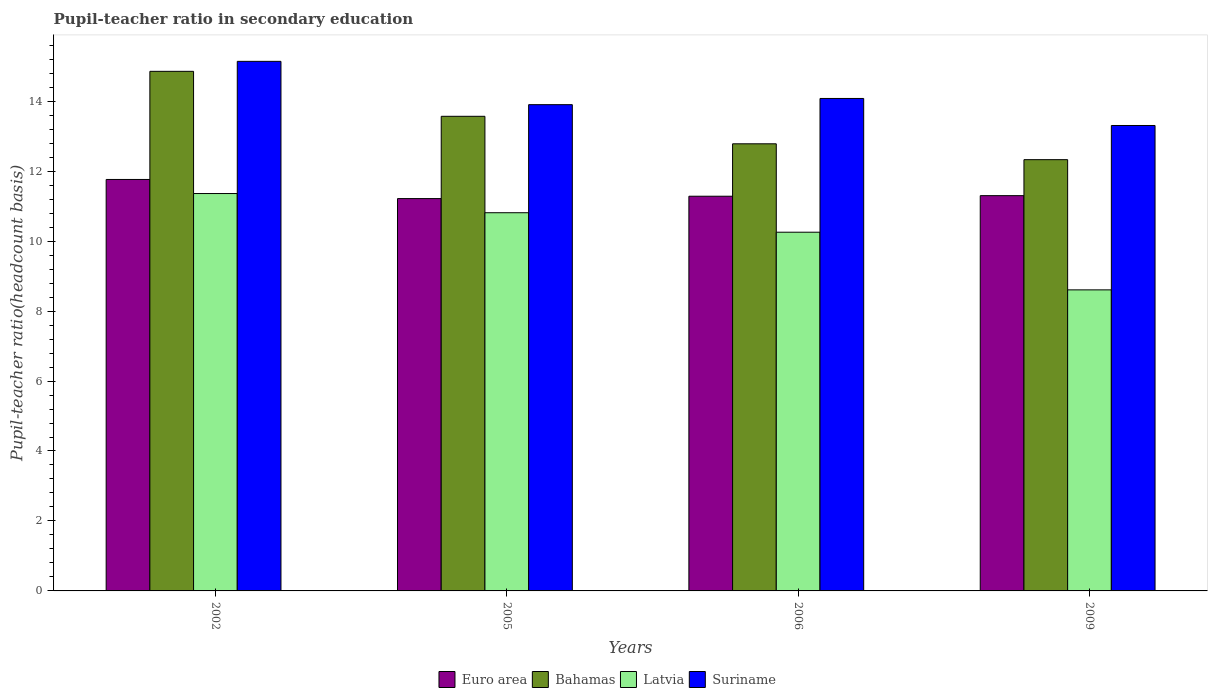How many different coloured bars are there?
Offer a very short reply. 4. How many groups of bars are there?
Your answer should be very brief. 4. Are the number of bars per tick equal to the number of legend labels?
Your answer should be very brief. Yes. Are the number of bars on each tick of the X-axis equal?
Your answer should be compact. Yes. What is the pupil-teacher ratio in secondary education in Latvia in 2009?
Your answer should be very brief. 8.61. Across all years, what is the maximum pupil-teacher ratio in secondary education in Bahamas?
Your answer should be very brief. 14.85. Across all years, what is the minimum pupil-teacher ratio in secondary education in Euro area?
Your response must be concise. 11.22. In which year was the pupil-teacher ratio in secondary education in Latvia minimum?
Your response must be concise. 2009. What is the total pupil-teacher ratio in secondary education in Euro area in the graph?
Keep it short and to the point. 45.56. What is the difference between the pupil-teacher ratio in secondary education in Bahamas in 2002 and that in 2005?
Your answer should be compact. 1.29. What is the difference between the pupil-teacher ratio in secondary education in Bahamas in 2005 and the pupil-teacher ratio in secondary education in Euro area in 2009?
Provide a succinct answer. 2.27. What is the average pupil-teacher ratio in secondary education in Latvia per year?
Provide a succinct answer. 10.26. In the year 2002, what is the difference between the pupil-teacher ratio in secondary education in Bahamas and pupil-teacher ratio in secondary education in Latvia?
Your answer should be compact. 3.49. What is the ratio of the pupil-teacher ratio in secondary education in Latvia in 2005 to that in 2009?
Ensure brevity in your answer.  1.26. Is the pupil-teacher ratio in secondary education in Bahamas in 2002 less than that in 2005?
Give a very brief answer. No. What is the difference between the highest and the second highest pupil-teacher ratio in secondary education in Latvia?
Your answer should be very brief. 0.55. What is the difference between the highest and the lowest pupil-teacher ratio in secondary education in Euro area?
Your answer should be very brief. 0.55. Is the sum of the pupil-teacher ratio in secondary education in Suriname in 2005 and 2006 greater than the maximum pupil-teacher ratio in secondary education in Bahamas across all years?
Your answer should be compact. Yes. What does the 4th bar from the left in 2002 represents?
Offer a very short reply. Suriname. What does the 3rd bar from the right in 2009 represents?
Ensure brevity in your answer.  Bahamas. Are all the bars in the graph horizontal?
Your response must be concise. No. How many years are there in the graph?
Provide a short and direct response. 4. Are the values on the major ticks of Y-axis written in scientific E-notation?
Keep it short and to the point. No. Where does the legend appear in the graph?
Ensure brevity in your answer.  Bottom center. How are the legend labels stacked?
Keep it short and to the point. Horizontal. What is the title of the graph?
Offer a very short reply. Pupil-teacher ratio in secondary education. Does "Liechtenstein" appear as one of the legend labels in the graph?
Provide a short and direct response. No. What is the label or title of the X-axis?
Provide a short and direct response. Years. What is the label or title of the Y-axis?
Your response must be concise. Pupil-teacher ratio(headcount basis). What is the Pupil-teacher ratio(headcount basis) of Euro area in 2002?
Provide a succinct answer. 11.76. What is the Pupil-teacher ratio(headcount basis) in Bahamas in 2002?
Make the answer very short. 14.85. What is the Pupil-teacher ratio(headcount basis) in Latvia in 2002?
Provide a succinct answer. 11.36. What is the Pupil-teacher ratio(headcount basis) in Suriname in 2002?
Give a very brief answer. 15.14. What is the Pupil-teacher ratio(headcount basis) of Euro area in 2005?
Your answer should be very brief. 11.22. What is the Pupil-teacher ratio(headcount basis) of Bahamas in 2005?
Your response must be concise. 13.57. What is the Pupil-teacher ratio(headcount basis) in Latvia in 2005?
Make the answer very short. 10.81. What is the Pupil-teacher ratio(headcount basis) of Suriname in 2005?
Your response must be concise. 13.9. What is the Pupil-teacher ratio(headcount basis) of Euro area in 2006?
Offer a terse response. 11.28. What is the Pupil-teacher ratio(headcount basis) of Bahamas in 2006?
Your answer should be compact. 12.78. What is the Pupil-teacher ratio(headcount basis) in Latvia in 2006?
Keep it short and to the point. 10.25. What is the Pupil-teacher ratio(headcount basis) of Suriname in 2006?
Offer a very short reply. 14.08. What is the Pupil-teacher ratio(headcount basis) of Euro area in 2009?
Your response must be concise. 11.3. What is the Pupil-teacher ratio(headcount basis) in Bahamas in 2009?
Your response must be concise. 12.33. What is the Pupil-teacher ratio(headcount basis) of Latvia in 2009?
Your response must be concise. 8.61. What is the Pupil-teacher ratio(headcount basis) in Suriname in 2009?
Your answer should be compact. 13.31. Across all years, what is the maximum Pupil-teacher ratio(headcount basis) of Euro area?
Offer a terse response. 11.76. Across all years, what is the maximum Pupil-teacher ratio(headcount basis) in Bahamas?
Give a very brief answer. 14.85. Across all years, what is the maximum Pupil-teacher ratio(headcount basis) of Latvia?
Ensure brevity in your answer.  11.36. Across all years, what is the maximum Pupil-teacher ratio(headcount basis) of Suriname?
Offer a terse response. 15.14. Across all years, what is the minimum Pupil-teacher ratio(headcount basis) in Euro area?
Offer a very short reply. 11.22. Across all years, what is the minimum Pupil-teacher ratio(headcount basis) in Bahamas?
Provide a succinct answer. 12.33. Across all years, what is the minimum Pupil-teacher ratio(headcount basis) in Latvia?
Provide a succinct answer. 8.61. Across all years, what is the minimum Pupil-teacher ratio(headcount basis) in Suriname?
Make the answer very short. 13.31. What is the total Pupil-teacher ratio(headcount basis) in Euro area in the graph?
Ensure brevity in your answer.  45.56. What is the total Pupil-teacher ratio(headcount basis) in Bahamas in the graph?
Keep it short and to the point. 53.53. What is the total Pupil-teacher ratio(headcount basis) of Latvia in the graph?
Your response must be concise. 41.03. What is the total Pupil-teacher ratio(headcount basis) in Suriname in the graph?
Give a very brief answer. 56.42. What is the difference between the Pupil-teacher ratio(headcount basis) in Euro area in 2002 and that in 2005?
Your answer should be very brief. 0.55. What is the difference between the Pupil-teacher ratio(headcount basis) in Bahamas in 2002 and that in 2005?
Ensure brevity in your answer.  1.29. What is the difference between the Pupil-teacher ratio(headcount basis) of Latvia in 2002 and that in 2005?
Ensure brevity in your answer.  0.55. What is the difference between the Pupil-teacher ratio(headcount basis) in Suriname in 2002 and that in 2005?
Provide a succinct answer. 1.24. What is the difference between the Pupil-teacher ratio(headcount basis) in Euro area in 2002 and that in 2006?
Give a very brief answer. 0.48. What is the difference between the Pupil-teacher ratio(headcount basis) in Bahamas in 2002 and that in 2006?
Keep it short and to the point. 2.07. What is the difference between the Pupil-teacher ratio(headcount basis) in Latvia in 2002 and that in 2006?
Make the answer very short. 1.11. What is the difference between the Pupil-teacher ratio(headcount basis) of Suriname in 2002 and that in 2006?
Offer a terse response. 1.06. What is the difference between the Pupil-teacher ratio(headcount basis) of Euro area in 2002 and that in 2009?
Offer a very short reply. 0.46. What is the difference between the Pupil-teacher ratio(headcount basis) of Bahamas in 2002 and that in 2009?
Give a very brief answer. 2.53. What is the difference between the Pupil-teacher ratio(headcount basis) of Latvia in 2002 and that in 2009?
Ensure brevity in your answer.  2.75. What is the difference between the Pupil-teacher ratio(headcount basis) of Suriname in 2002 and that in 2009?
Offer a terse response. 1.83. What is the difference between the Pupil-teacher ratio(headcount basis) in Euro area in 2005 and that in 2006?
Your response must be concise. -0.07. What is the difference between the Pupil-teacher ratio(headcount basis) of Bahamas in 2005 and that in 2006?
Provide a short and direct response. 0.79. What is the difference between the Pupil-teacher ratio(headcount basis) in Latvia in 2005 and that in 2006?
Offer a terse response. 0.56. What is the difference between the Pupil-teacher ratio(headcount basis) in Suriname in 2005 and that in 2006?
Your response must be concise. -0.18. What is the difference between the Pupil-teacher ratio(headcount basis) of Euro area in 2005 and that in 2009?
Provide a short and direct response. -0.08. What is the difference between the Pupil-teacher ratio(headcount basis) of Bahamas in 2005 and that in 2009?
Ensure brevity in your answer.  1.24. What is the difference between the Pupil-teacher ratio(headcount basis) in Latvia in 2005 and that in 2009?
Provide a succinct answer. 2.21. What is the difference between the Pupil-teacher ratio(headcount basis) in Suriname in 2005 and that in 2009?
Your answer should be compact. 0.6. What is the difference between the Pupil-teacher ratio(headcount basis) in Euro area in 2006 and that in 2009?
Your answer should be compact. -0.02. What is the difference between the Pupil-teacher ratio(headcount basis) in Bahamas in 2006 and that in 2009?
Your answer should be very brief. 0.45. What is the difference between the Pupil-teacher ratio(headcount basis) in Latvia in 2006 and that in 2009?
Offer a very short reply. 1.65. What is the difference between the Pupil-teacher ratio(headcount basis) of Suriname in 2006 and that in 2009?
Provide a succinct answer. 0.77. What is the difference between the Pupil-teacher ratio(headcount basis) of Euro area in 2002 and the Pupil-teacher ratio(headcount basis) of Bahamas in 2005?
Offer a very short reply. -1.81. What is the difference between the Pupil-teacher ratio(headcount basis) in Euro area in 2002 and the Pupil-teacher ratio(headcount basis) in Latvia in 2005?
Give a very brief answer. 0.95. What is the difference between the Pupil-teacher ratio(headcount basis) of Euro area in 2002 and the Pupil-teacher ratio(headcount basis) of Suriname in 2005?
Make the answer very short. -2.14. What is the difference between the Pupil-teacher ratio(headcount basis) in Bahamas in 2002 and the Pupil-teacher ratio(headcount basis) in Latvia in 2005?
Your answer should be very brief. 4.04. What is the difference between the Pupil-teacher ratio(headcount basis) in Bahamas in 2002 and the Pupil-teacher ratio(headcount basis) in Suriname in 2005?
Your response must be concise. 0.95. What is the difference between the Pupil-teacher ratio(headcount basis) of Latvia in 2002 and the Pupil-teacher ratio(headcount basis) of Suriname in 2005?
Keep it short and to the point. -2.54. What is the difference between the Pupil-teacher ratio(headcount basis) of Euro area in 2002 and the Pupil-teacher ratio(headcount basis) of Bahamas in 2006?
Make the answer very short. -1.02. What is the difference between the Pupil-teacher ratio(headcount basis) in Euro area in 2002 and the Pupil-teacher ratio(headcount basis) in Latvia in 2006?
Give a very brief answer. 1.51. What is the difference between the Pupil-teacher ratio(headcount basis) in Euro area in 2002 and the Pupil-teacher ratio(headcount basis) in Suriname in 2006?
Give a very brief answer. -2.32. What is the difference between the Pupil-teacher ratio(headcount basis) in Bahamas in 2002 and the Pupil-teacher ratio(headcount basis) in Latvia in 2006?
Keep it short and to the point. 4.6. What is the difference between the Pupil-teacher ratio(headcount basis) in Bahamas in 2002 and the Pupil-teacher ratio(headcount basis) in Suriname in 2006?
Offer a terse response. 0.78. What is the difference between the Pupil-teacher ratio(headcount basis) in Latvia in 2002 and the Pupil-teacher ratio(headcount basis) in Suriname in 2006?
Offer a very short reply. -2.72. What is the difference between the Pupil-teacher ratio(headcount basis) of Euro area in 2002 and the Pupil-teacher ratio(headcount basis) of Bahamas in 2009?
Make the answer very short. -0.57. What is the difference between the Pupil-teacher ratio(headcount basis) in Euro area in 2002 and the Pupil-teacher ratio(headcount basis) in Latvia in 2009?
Your response must be concise. 3.16. What is the difference between the Pupil-teacher ratio(headcount basis) in Euro area in 2002 and the Pupil-teacher ratio(headcount basis) in Suriname in 2009?
Provide a short and direct response. -1.54. What is the difference between the Pupil-teacher ratio(headcount basis) of Bahamas in 2002 and the Pupil-teacher ratio(headcount basis) of Latvia in 2009?
Make the answer very short. 6.25. What is the difference between the Pupil-teacher ratio(headcount basis) of Bahamas in 2002 and the Pupil-teacher ratio(headcount basis) of Suriname in 2009?
Provide a succinct answer. 1.55. What is the difference between the Pupil-teacher ratio(headcount basis) of Latvia in 2002 and the Pupil-teacher ratio(headcount basis) of Suriname in 2009?
Provide a short and direct response. -1.95. What is the difference between the Pupil-teacher ratio(headcount basis) in Euro area in 2005 and the Pupil-teacher ratio(headcount basis) in Bahamas in 2006?
Provide a succinct answer. -1.57. What is the difference between the Pupil-teacher ratio(headcount basis) in Euro area in 2005 and the Pupil-teacher ratio(headcount basis) in Latvia in 2006?
Your answer should be very brief. 0.96. What is the difference between the Pupil-teacher ratio(headcount basis) in Euro area in 2005 and the Pupil-teacher ratio(headcount basis) in Suriname in 2006?
Your answer should be compact. -2.86. What is the difference between the Pupil-teacher ratio(headcount basis) in Bahamas in 2005 and the Pupil-teacher ratio(headcount basis) in Latvia in 2006?
Keep it short and to the point. 3.31. What is the difference between the Pupil-teacher ratio(headcount basis) of Bahamas in 2005 and the Pupil-teacher ratio(headcount basis) of Suriname in 2006?
Your answer should be very brief. -0.51. What is the difference between the Pupil-teacher ratio(headcount basis) of Latvia in 2005 and the Pupil-teacher ratio(headcount basis) of Suriname in 2006?
Ensure brevity in your answer.  -3.27. What is the difference between the Pupil-teacher ratio(headcount basis) in Euro area in 2005 and the Pupil-teacher ratio(headcount basis) in Bahamas in 2009?
Give a very brief answer. -1.11. What is the difference between the Pupil-teacher ratio(headcount basis) in Euro area in 2005 and the Pupil-teacher ratio(headcount basis) in Latvia in 2009?
Keep it short and to the point. 2.61. What is the difference between the Pupil-teacher ratio(headcount basis) in Euro area in 2005 and the Pupil-teacher ratio(headcount basis) in Suriname in 2009?
Your answer should be compact. -2.09. What is the difference between the Pupil-teacher ratio(headcount basis) of Bahamas in 2005 and the Pupil-teacher ratio(headcount basis) of Latvia in 2009?
Ensure brevity in your answer.  4.96. What is the difference between the Pupil-teacher ratio(headcount basis) in Bahamas in 2005 and the Pupil-teacher ratio(headcount basis) in Suriname in 2009?
Your response must be concise. 0.26. What is the difference between the Pupil-teacher ratio(headcount basis) in Latvia in 2005 and the Pupil-teacher ratio(headcount basis) in Suriname in 2009?
Your answer should be very brief. -2.49. What is the difference between the Pupil-teacher ratio(headcount basis) of Euro area in 2006 and the Pupil-teacher ratio(headcount basis) of Bahamas in 2009?
Keep it short and to the point. -1.05. What is the difference between the Pupil-teacher ratio(headcount basis) in Euro area in 2006 and the Pupil-teacher ratio(headcount basis) in Latvia in 2009?
Keep it short and to the point. 2.68. What is the difference between the Pupil-teacher ratio(headcount basis) in Euro area in 2006 and the Pupil-teacher ratio(headcount basis) in Suriname in 2009?
Offer a very short reply. -2.02. What is the difference between the Pupil-teacher ratio(headcount basis) of Bahamas in 2006 and the Pupil-teacher ratio(headcount basis) of Latvia in 2009?
Provide a short and direct response. 4.18. What is the difference between the Pupil-teacher ratio(headcount basis) of Bahamas in 2006 and the Pupil-teacher ratio(headcount basis) of Suriname in 2009?
Your answer should be compact. -0.52. What is the difference between the Pupil-teacher ratio(headcount basis) of Latvia in 2006 and the Pupil-teacher ratio(headcount basis) of Suriname in 2009?
Your response must be concise. -3.05. What is the average Pupil-teacher ratio(headcount basis) of Euro area per year?
Provide a short and direct response. 11.39. What is the average Pupil-teacher ratio(headcount basis) of Bahamas per year?
Provide a short and direct response. 13.38. What is the average Pupil-teacher ratio(headcount basis) of Latvia per year?
Keep it short and to the point. 10.26. What is the average Pupil-teacher ratio(headcount basis) in Suriname per year?
Provide a succinct answer. 14.11. In the year 2002, what is the difference between the Pupil-teacher ratio(headcount basis) of Euro area and Pupil-teacher ratio(headcount basis) of Bahamas?
Offer a very short reply. -3.09. In the year 2002, what is the difference between the Pupil-teacher ratio(headcount basis) of Euro area and Pupil-teacher ratio(headcount basis) of Latvia?
Your answer should be compact. 0.4. In the year 2002, what is the difference between the Pupil-teacher ratio(headcount basis) of Euro area and Pupil-teacher ratio(headcount basis) of Suriname?
Give a very brief answer. -3.38. In the year 2002, what is the difference between the Pupil-teacher ratio(headcount basis) of Bahamas and Pupil-teacher ratio(headcount basis) of Latvia?
Your answer should be very brief. 3.49. In the year 2002, what is the difference between the Pupil-teacher ratio(headcount basis) of Bahamas and Pupil-teacher ratio(headcount basis) of Suriname?
Keep it short and to the point. -0.29. In the year 2002, what is the difference between the Pupil-teacher ratio(headcount basis) in Latvia and Pupil-teacher ratio(headcount basis) in Suriname?
Your answer should be compact. -3.78. In the year 2005, what is the difference between the Pupil-teacher ratio(headcount basis) in Euro area and Pupil-teacher ratio(headcount basis) in Bahamas?
Provide a succinct answer. -2.35. In the year 2005, what is the difference between the Pupil-teacher ratio(headcount basis) of Euro area and Pupil-teacher ratio(headcount basis) of Latvia?
Your answer should be very brief. 0.4. In the year 2005, what is the difference between the Pupil-teacher ratio(headcount basis) in Euro area and Pupil-teacher ratio(headcount basis) in Suriname?
Provide a succinct answer. -2.69. In the year 2005, what is the difference between the Pupil-teacher ratio(headcount basis) in Bahamas and Pupil-teacher ratio(headcount basis) in Latvia?
Your answer should be compact. 2.76. In the year 2005, what is the difference between the Pupil-teacher ratio(headcount basis) in Bahamas and Pupil-teacher ratio(headcount basis) in Suriname?
Provide a succinct answer. -0.33. In the year 2005, what is the difference between the Pupil-teacher ratio(headcount basis) in Latvia and Pupil-teacher ratio(headcount basis) in Suriname?
Your answer should be compact. -3.09. In the year 2006, what is the difference between the Pupil-teacher ratio(headcount basis) in Euro area and Pupil-teacher ratio(headcount basis) in Bahamas?
Your answer should be compact. -1.5. In the year 2006, what is the difference between the Pupil-teacher ratio(headcount basis) of Euro area and Pupil-teacher ratio(headcount basis) of Latvia?
Offer a terse response. 1.03. In the year 2006, what is the difference between the Pupil-teacher ratio(headcount basis) in Euro area and Pupil-teacher ratio(headcount basis) in Suriname?
Offer a terse response. -2.79. In the year 2006, what is the difference between the Pupil-teacher ratio(headcount basis) in Bahamas and Pupil-teacher ratio(headcount basis) in Latvia?
Provide a succinct answer. 2.53. In the year 2006, what is the difference between the Pupil-teacher ratio(headcount basis) of Bahamas and Pupil-teacher ratio(headcount basis) of Suriname?
Your answer should be compact. -1.3. In the year 2006, what is the difference between the Pupil-teacher ratio(headcount basis) in Latvia and Pupil-teacher ratio(headcount basis) in Suriname?
Provide a short and direct response. -3.82. In the year 2009, what is the difference between the Pupil-teacher ratio(headcount basis) in Euro area and Pupil-teacher ratio(headcount basis) in Bahamas?
Keep it short and to the point. -1.03. In the year 2009, what is the difference between the Pupil-teacher ratio(headcount basis) in Euro area and Pupil-teacher ratio(headcount basis) in Latvia?
Offer a terse response. 2.69. In the year 2009, what is the difference between the Pupil-teacher ratio(headcount basis) of Euro area and Pupil-teacher ratio(headcount basis) of Suriname?
Keep it short and to the point. -2.01. In the year 2009, what is the difference between the Pupil-teacher ratio(headcount basis) of Bahamas and Pupil-teacher ratio(headcount basis) of Latvia?
Your answer should be very brief. 3.72. In the year 2009, what is the difference between the Pupil-teacher ratio(headcount basis) in Bahamas and Pupil-teacher ratio(headcount basis) in Suriname?
Offer a terse response. -0.98. In the year 2009, what is the difference between the Pupil-teacher ratio(headcount basis) of Latvia and Pupil-teacher ratio(headcount basis) of Suriname?
Your answer should be compact. -4.7. What is the ratio of the Pupil-teacher ratio(headcount basis) of Euro area in 2002 to that in 2005?
Offer a terse response. 1.05. What is the ratio of the Pupil-teacher ratio(headcount basis) of Bahamas in 2002 to that in 2005?
Give a very brief answer. 1.09. What is the ratio of the Pupil-teacher ratio(headcount basis) of Latvia in 2002 to that in 2005?
Your answer should be very brief. 1.05. What is the ratio of the Pupil-teacher ratio(headcount basis) in Suriname in 2002 to that in 2005?
Offer a very short reply. 1.09. What is the ratio of the Pupil-teacher ratio(headcount basis) of Euro area in 2002 to that in 2006?
Provide a succinct answer. 1.04. What is the ratio of the Pupil-teacher ratio(headcount basis) of Bahamas in 2002 to that in 2006?
Keep it short and to the point. 1.16. What is the ratio of the Pupil-teacher ratio(headcount basis) of Latvia in 2002 to that in 2006?
Your answer should be compact. 1.11. What is the ratio of the Pupil-teacher ratio(headcount basis) in Suriname in 2002 to that in 2006?
Provide a succinct answer. 1.08. What is the ratio of the Pupil-teacher ratio(headcount basis) of Euro area in 2002 to that in 2009?
Give a very brief answer. 1.04. What is the ratio of the Pupil-teacher ratio(headcount basis) of Bahamas in 2002 to that in 2009?
Provide a short and direct response. 1.2. What is the ratio of the Pupil-teacher ratio(headcount basis) in Latvia in 2002 to that in 2009?
Give a very brief answer. 1.32. What is the ratio of the Pupil-teacher ratio(headcount basis) in Suriname in 2002 to that in 2009?
Your answer should be compact. 1.14. What is the ratio of the Pupil-teacher ratio(headcount basis) in Bahamas in 2005 to that in 2006?
Make the answer very short. 1.06. What is the ratio of the Pupil-teacher ratio(headcount basis) of Latvia in 2005 to that in 2006?
Ensure brevity in your answer.  1.05. What is the ratio of the Pupil-teacher ratio(headcount basis) in Suriname in 2005 to that in 2006?
Provide a short and direct response. 0.99. What is the ratio of the Pupil-teacher ratio(headcount basis) in Euro area in 2005 to that in 2009?
Give a very brief answer. 0.99. What is the ratio of the Pupil-teacher ratio(headcount basis) of Bahamas in 2005 to that in 2009?
Provide a succinct answer. 1.1. What is the ratio of the Pupil-teacher ratio(headcount basis) in Latvia in 2005 to that in 2009?
Offer a very short reply. 1.26. What is the ratio of the Pupil-teacher ratio(headcount basis) in Suriname in 2005 to that in 2009?
Offer a very short reply. 1.04. What is the ratio of the Pupil-teacher ratio(headcount basis) of Euro area in 2006 to that in 2009?
Your response must be concise. 1. What is the ratio of the Pupil-teacher ratio(headcount basis) in Bahamas in 2006 to that in 2009?
Provide a succinct answer. 1.04. What is the ratio of the Pupil-teacher ratio(headcount basis) of Latvia in 2006 to that in 2009?
Give a very brief answer. 1.19. What is the ratio of the Pupil-teacher ratio(headcount basis) in Suriname in 2006 to that in 2009?
Make the answer very short. 1.06. What is the difference between the highest and the second highest Pupil-teacher ratio(headcount basis) of Euro area?
Give a very brief answer. 0.46. What is the difference between the highest and the second highest Pupil-teacher ratio(headcount basis) in Bahamas?
Make the answer very short. 1.29. What is the difference between the highest and the second highest Pupil-teacher ratio(headcount basis) of Latvia?
Keep it short and to the point. 0.55. What is the difference between the highest and the second highest Pupil-teacher ratio(headcount basis) of Suriname?
Ensure brevity in your answer.  1.06. What is the difference between the highest and the lowest Pupil-teacher ratio(headcount basis) in Euro area?
Provide a succinct answer. 0.55. What is the difference between the highest and the lowest Pupil-teacher ratio(headcount basis) of Bahamas?
Keep it short and to the point. 2.53. What is the difference between the highest and the lowest Pupil-teacher ratio(headcount basis) of Latvia?
Provide a short and direct response. 2.75. What is the difference between the highest and the lowest Pupil-teacher ratio(headcount basis) in Suriname?
Provide a short and direct response. 1.83. 